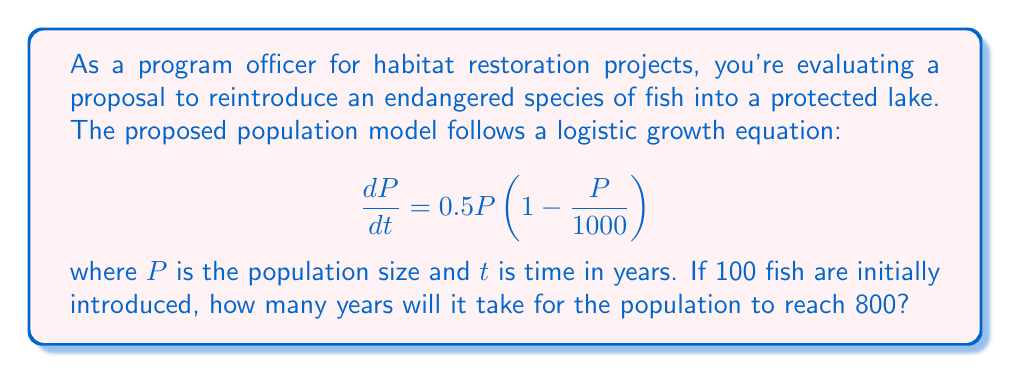Give your solution to this math problem. To solve this problem, we need to use the logistic differential equation and its solution. Let's approach this step-by-step:

1) The general form of the logistic differential equation is:

   $$\frac{dP}{dt} = rP\left(1 - \frac{P}{K}\right)$$

   where $r$ is the growth rate and $K$ is the carrying capacity.

2) Comparing our equation to the general form, we see that $r = 0.5$ and $K = 1000$.

3) The solution to the logistic differential equation is:

   $$P(t) = \frac{K}{1 + \left(\frac{K}{P_0} - 1\right)e^{-rt}}$$

   where $P_0$ is the initial population.

4) Substituting our values:

   $$P(t) = \frac{1000}{1 + \left(\frac{1000}{100} - 1\right)e^{-0.5t}}$$

5) We want to find $t$ when $P(t) = 800$. Let's substitute this:

   $$800 = \frac{1000}{1 + 9e^{-0.5t}}$$

6) Now, let's solve for $t$:

   $$1 + 9e^{-0.5t} = \frac{1000}{800} = 1.25$$
   
   $$9e^{-0.5t} = 0.25$$
   
   $$e^{-0.5t} = \frac{1}{36}$$

7) Taking the natural log of both sides:

   $$-0.5t = \ln\left(\frac{1}{36}\right) = -3.5835$$

8) Solving for $t$:

   $$t = \frac{3.5835}{0.5} = 7.167$$

Therefore, it will take approximately 7.167 years for the population to reach 800 fish.
Answer: 7.167 years 